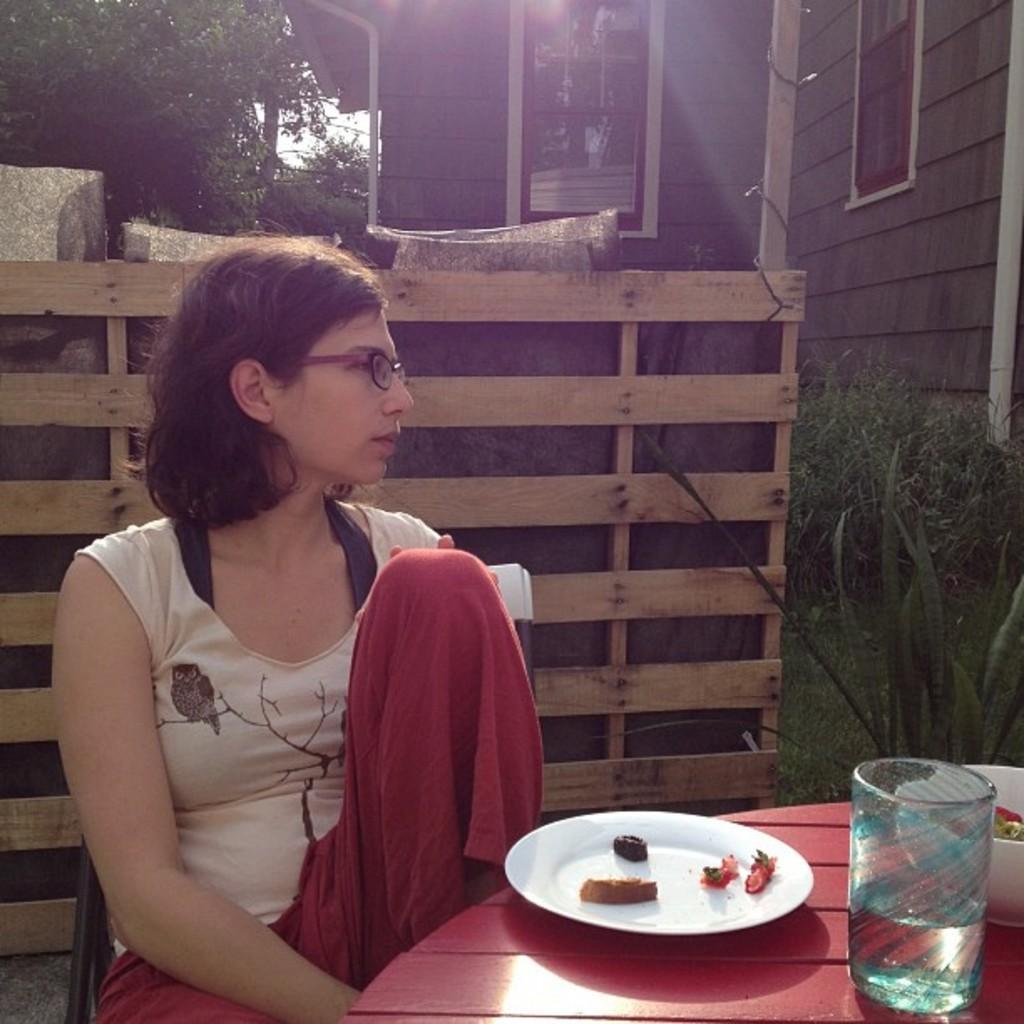How would you summarize this image in a sentence or two? A lady wearing a specs is sitting on a chair. In front of her there is a red table. On the table there is a plate and food items. A glass and a bowl is also there. Behind hey there is a wooden fencing and building and trees are there. 